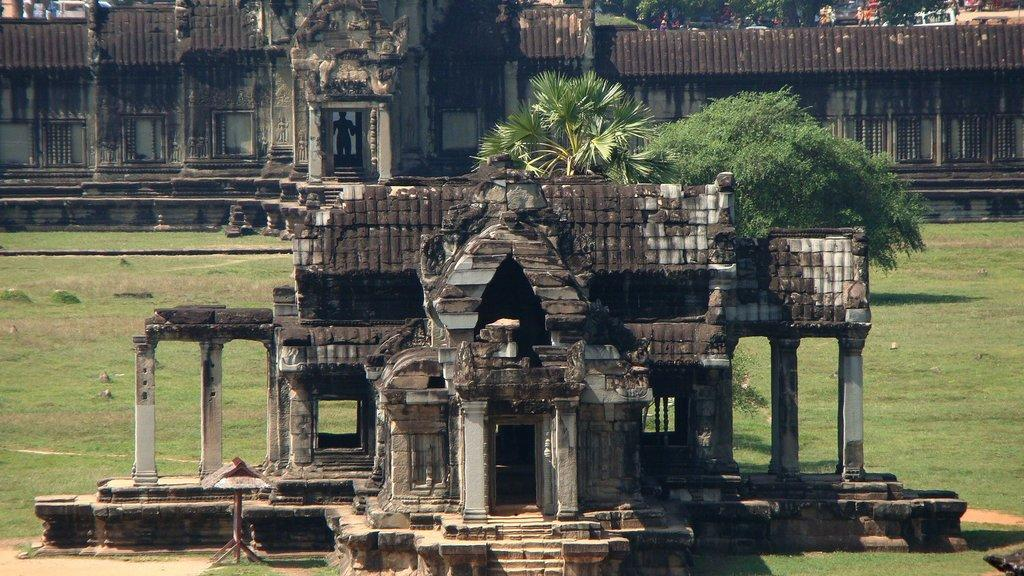What type of vegetation can be seen in the image? There is grass and trees in the image. What type of structures are visible in the image? There are buildings in the image. What can be seen in the background of the image? In the background, there are people and vehicles visible. What type of pets are visible in the image? There are no pets visible in the image. What type of ornament is hanging from the trees in the image? There is no ornament hanging from the trees in the image. 